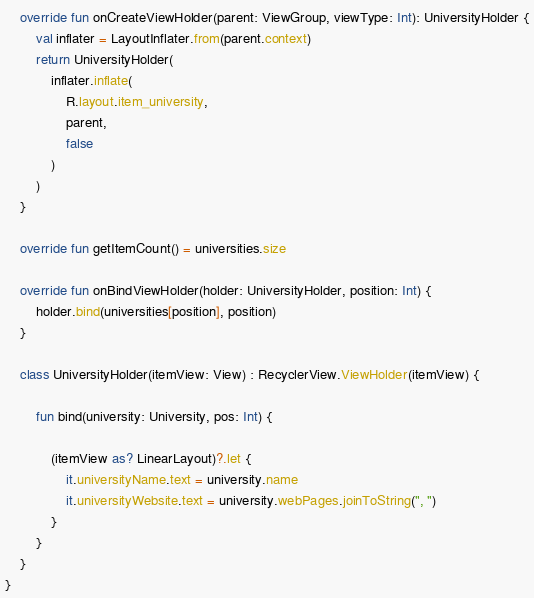<code> <loc_0><loc_0><loc_500><loc_500><_Kotlin_>
    override fun onCreateViewHolder(parent: ViewGroup, viewType: Int): UniversityHolder {
        val inflater = LayoutInflater.from(parent.context)
        return UniversityHolder(
            inflater.inflate(
                R.layout.item_university,
                parent,
                false
            )
        )
    }

    override fun getItemCount() = universities.size

    override fun onBindViewHolder(holder: UniversityHolder, position: Int) {
        holder.bind(universities[position], position)
    }

    class UniversityHolder(itemView: View) : RecyclerView.ViewHolder(itemView) {

        fun bind(university: University, pos: Int) {

            (itemView as? LinearLayout)?.let {
                it.universityName.text = university.name
                it.universityWebsite.text = university.webPages.joinToString(", ")
            }
        }
    }
}</code> 